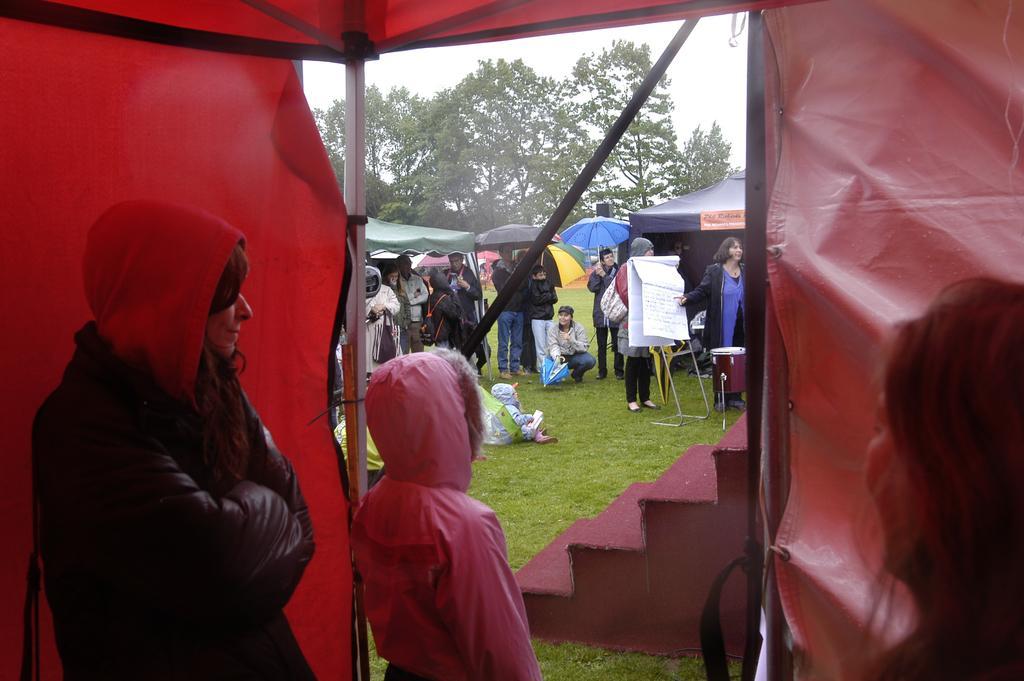Please provide a concise description of this image. In this picture I can observe red color tint. In the middle of the picture I can observe a stand to which charts are fixed. I can observe some people. There are men and women in this picture. 